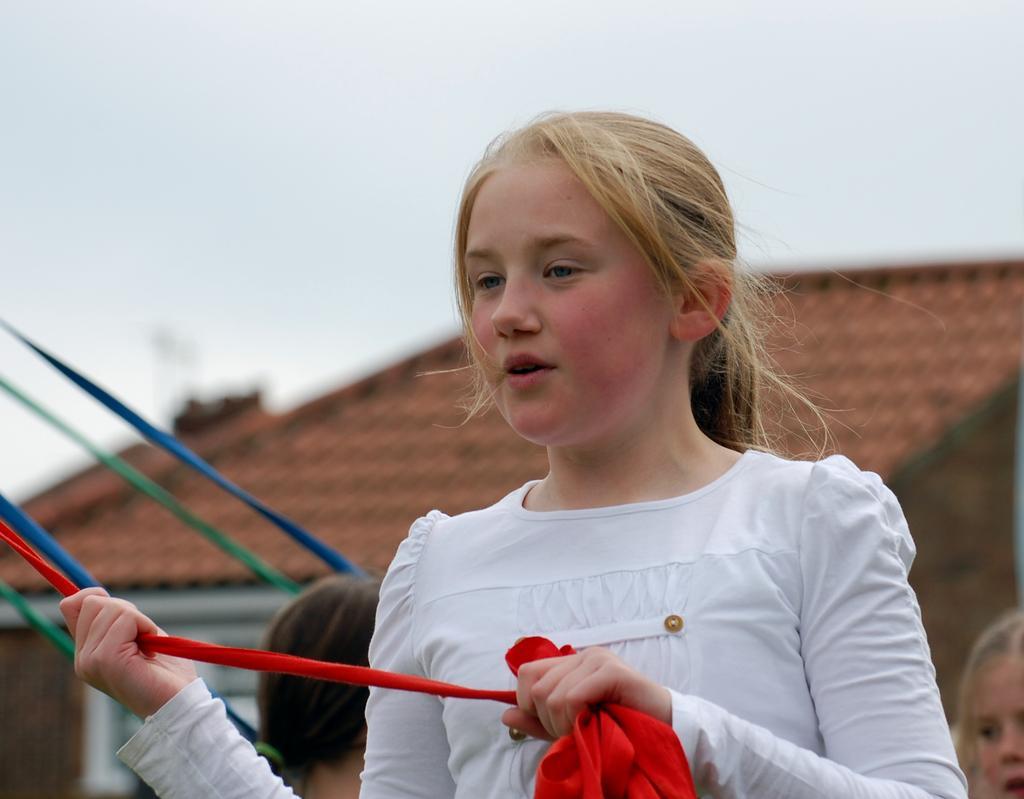Please provide a concise description of this image. This image is taken outdoors. At the top of the image there is the sky. In the background there is a house with a roof and a wall. There are two kids and there are a few ribbons. In the middle of the image a girl is standing and she is holding a ribbon in her hands. 